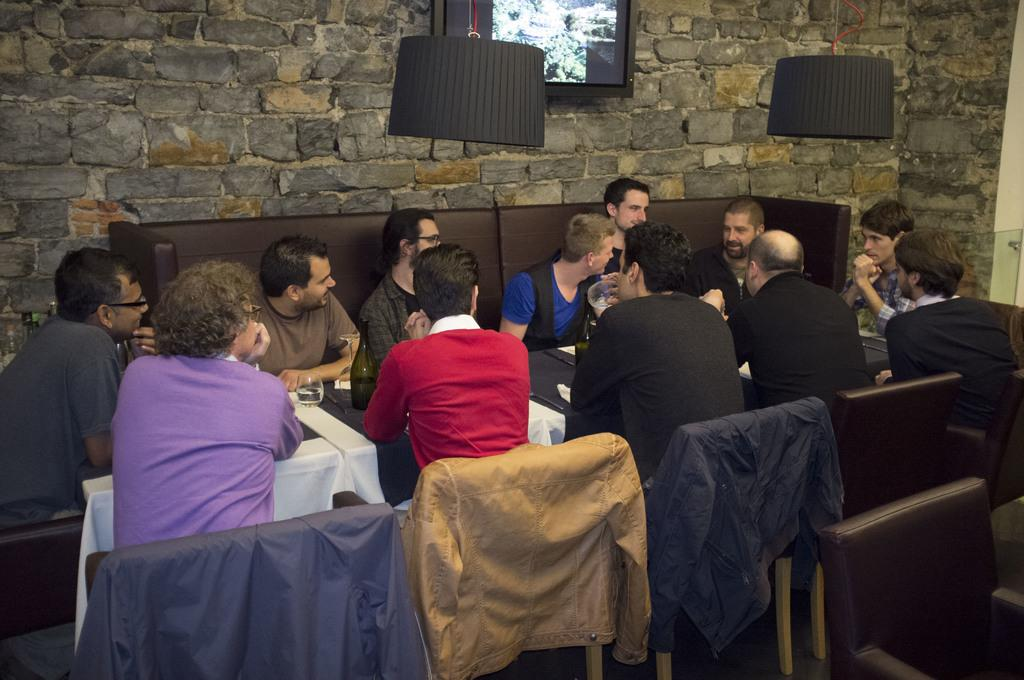How many people are in the image? There is a group of people in the image. What are the people doing in the image? The people are sitting on chairs. What is in front of the chairs? There is a table in front of the chairs. What is on the table? There is a bottle and a screen on top of the table. What type of plate is being used to serve the story in the image? There is no plate or story present in the image. 